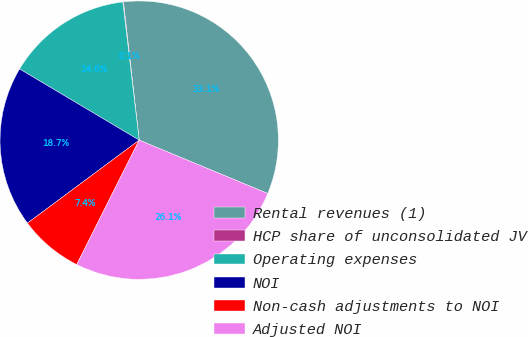Convert chart to OTSL. <chart><loc_0><loc_0><loc_500><loc_500><pie_chart><fcel>Rental revenues (1)<fcel>HCP share of unconsolidated JV<fcel>Operating expenses<fcel>NOI<fcel>Non-cash adjustments to NOI<fcel>Adjusted NOI<nl><fcel>33.07%<fcel>0.07%<fcel>14.58%<fcel>18.71%<fcel>7.43%<fcel>26.14%<nl></chart> 